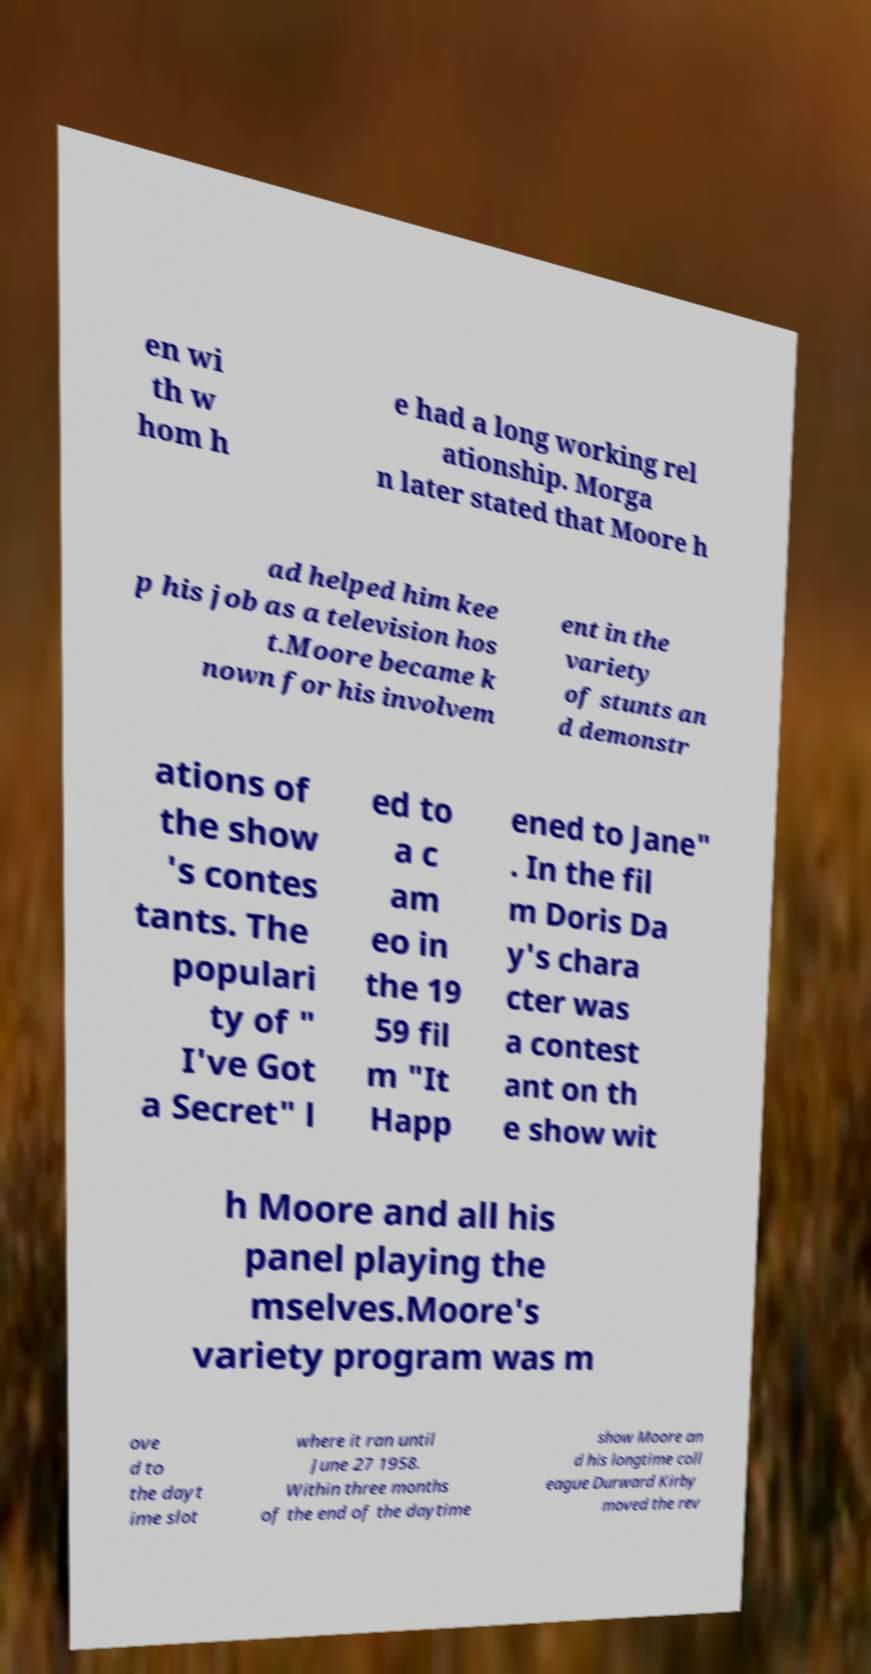Please identify and transcribe the text found in this image. en wi th w hom h e had a long working rel ationship. Morga n later stated that Moore h ad helped him kee p his job as a television hos t.Moore became k nown for his involvem ent in the variety of stunts an d demonstr ations of the show 's contes tants. The populari ty of " I've Got a Secret" l ed to a c am eo in the 19 59 fil m "It Happ ened to Jane" . In the fil m Doris Da y's chara cter was a contest ant on th e show wit h Moore and all his panel playing the mselves.Moore's variety program was m ove d to the dayt ime slot where it ran until June 27 1958. Within three months of the end of the daytime show Moore an d his longtime coll eague Durward Kirby moved the rev 